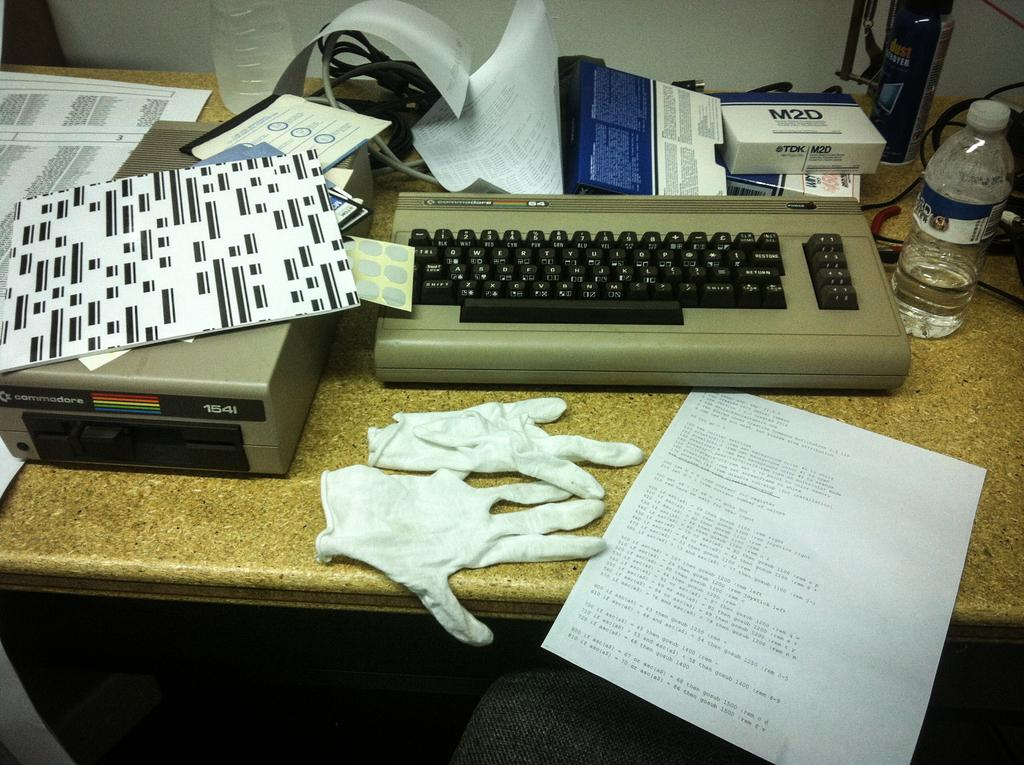<image>
Offer a succinct explanation of the picture presented. random objects on a desk including a commadore 1541 